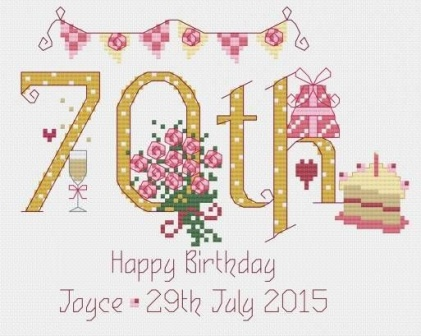Can you tell me more about the significance of the colors used in the image? Certainly! The image utilizes a prominent palette of pink and white, which are often associated with warmth, affection, and purity. These colors are typically chosen for celebrations to evoke a soft, welcoming, and festive atmosphere. Pink, often linked with love and happiness, enhances the joyful nature of the event, while white adds a touch of elegance and simplicity, ensuring that the overall appearance remains visually appealing and celebratory. 